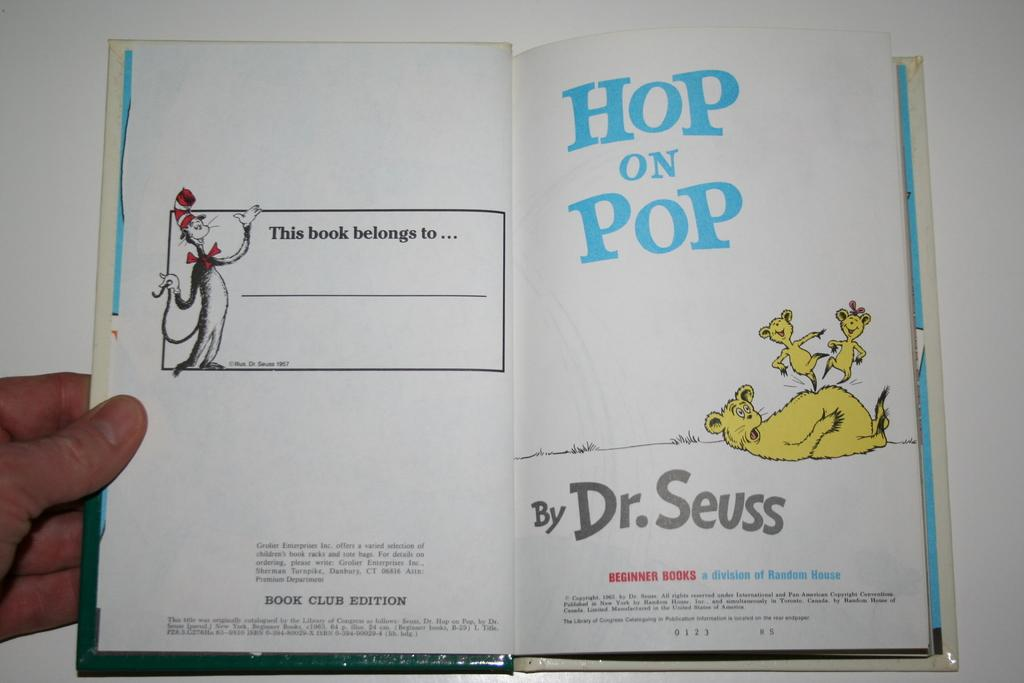What is the person in the image holding? The person is holding a book in the image. What can be found inside the book? The book contains pictures of animals and text. What is the color of the background at the bottom of the image? The background at the bottom of the image is white. How does the person in the image express disgust towards the mountain in the image? There is no mountain present in the image, and therefore no such expression of disgust can be observed. 